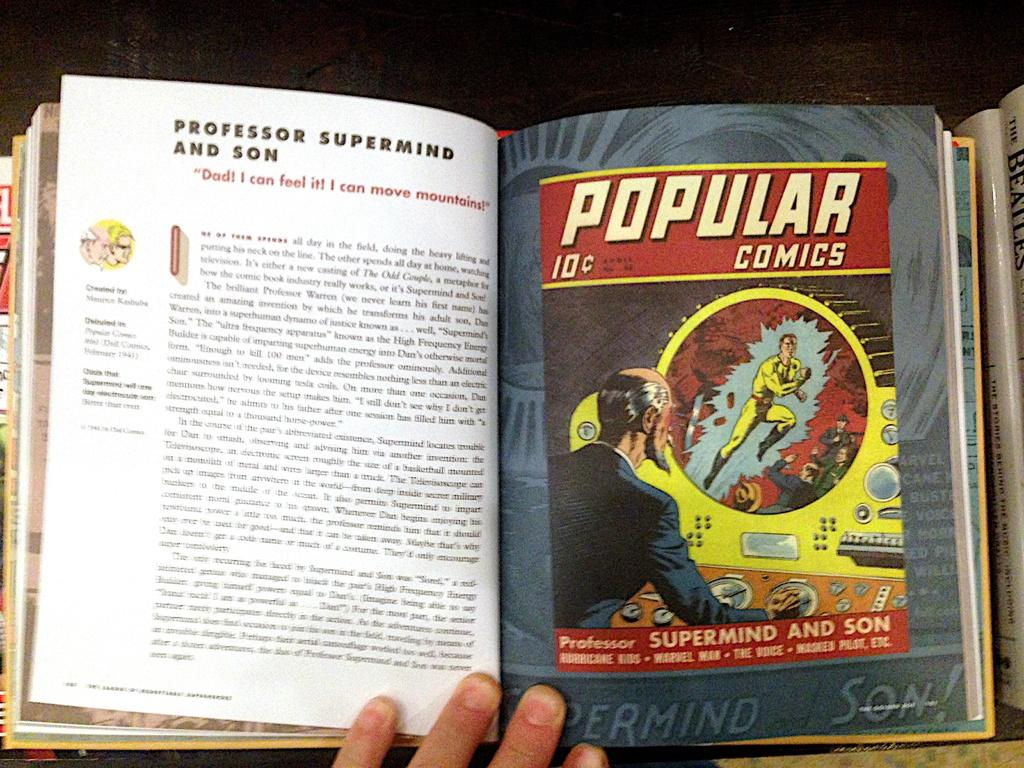<image>
Render a clear and concise summary of the photo. Someone is reading a book with popular comics 